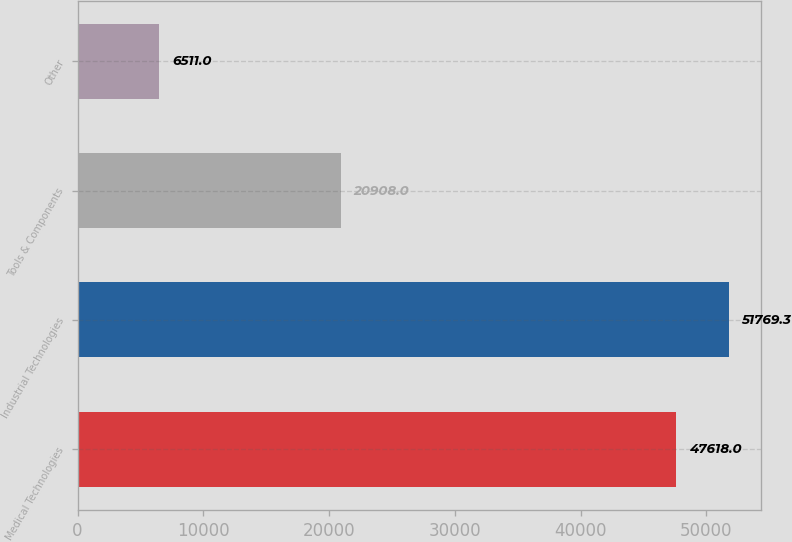Convert chart. <chart><loc_0><loc_0><loc_500><loc_500><bar_chart><fcel>Medical Technologies<fcel>Industrial Technologies<fcel>Tools & Components<fcel>Other<nl><fcel>47618<fcel>51769.3<fcel>20908<fcel>6511<nl></chart> 